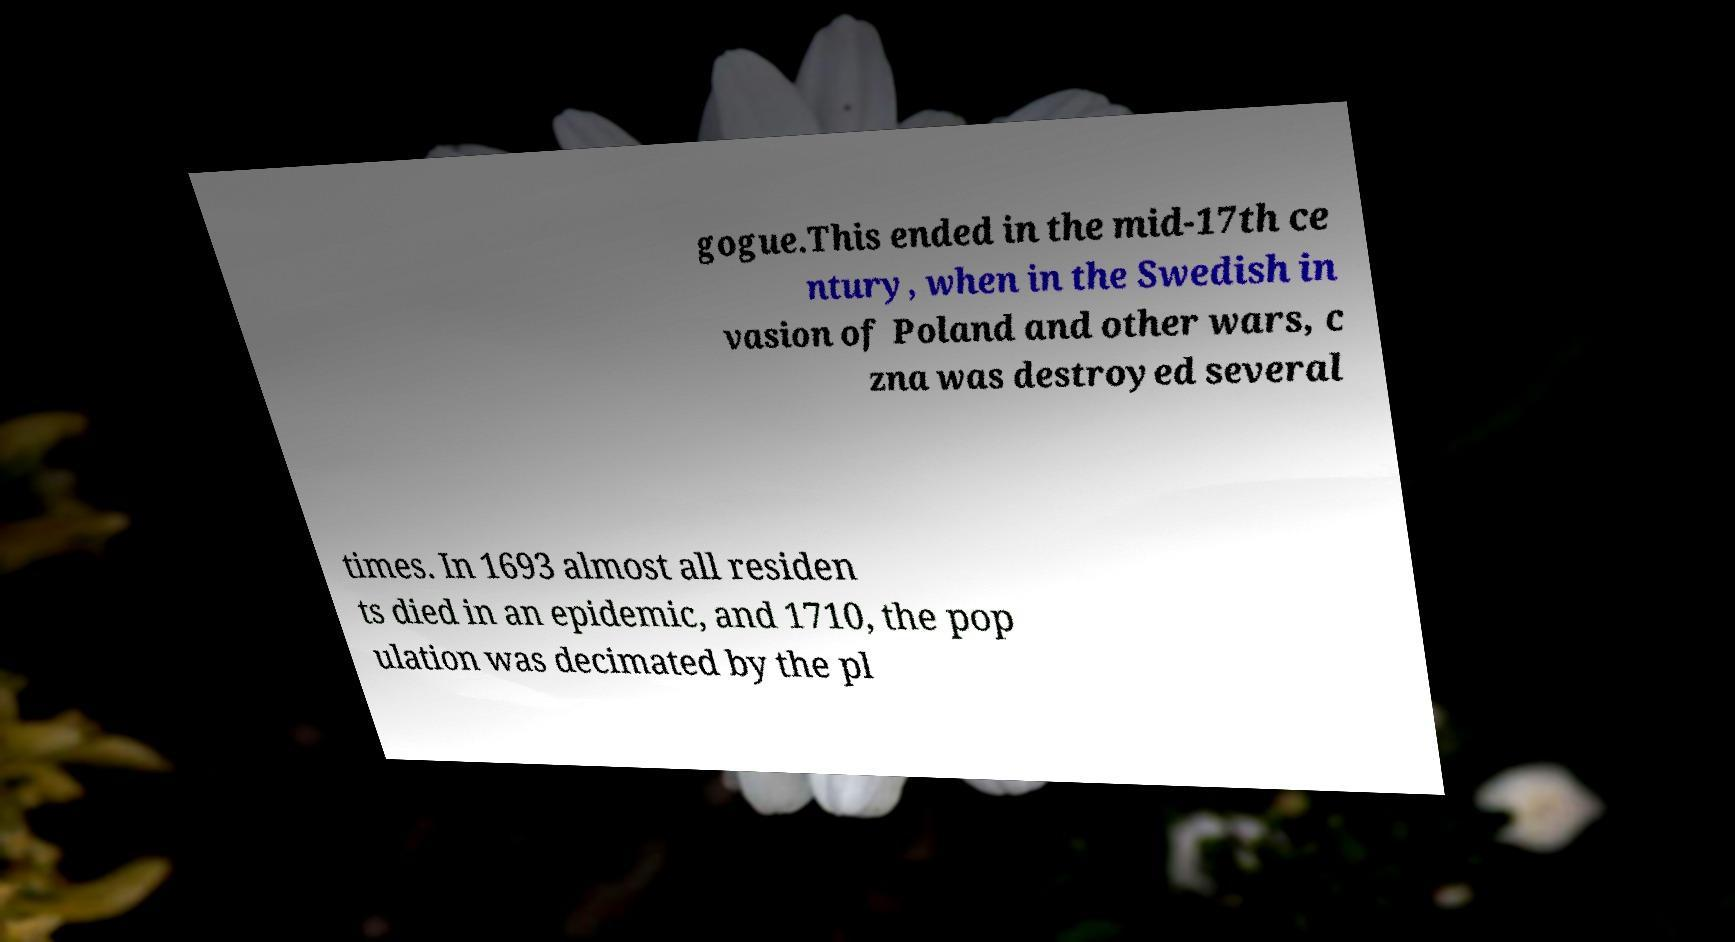For documentation purposes, I need the text within this image transcribed. Could you provide that? gogue.This ended in the mid-17th ce ntury, when in the Swedish in vasion of Poland and other wars, c zna was destroyed several times. In 1693 almost all residen ts died in an epidemic, and 1710, the pop ulation was decimated by the pl 